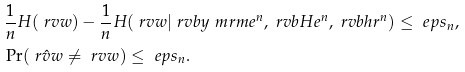Convert formula to latex. <formula><loc_0><loc_0><loc_500><loc_500>& \frac { 1 } { n } H ( \ r v w ) - \frac { 1 } { n } H ( \ r v w | \ r v b y _ { \ } m r m { e } ^ { n } , \ r v b H e ^ { n } , \ r v b h r ^ { n } ) \leq \ e p s _ { n } , \\ & \Pr ( \hat { \ r v w } \neq \ r v w ) \leq \ e p s _ { n } .</formula> 